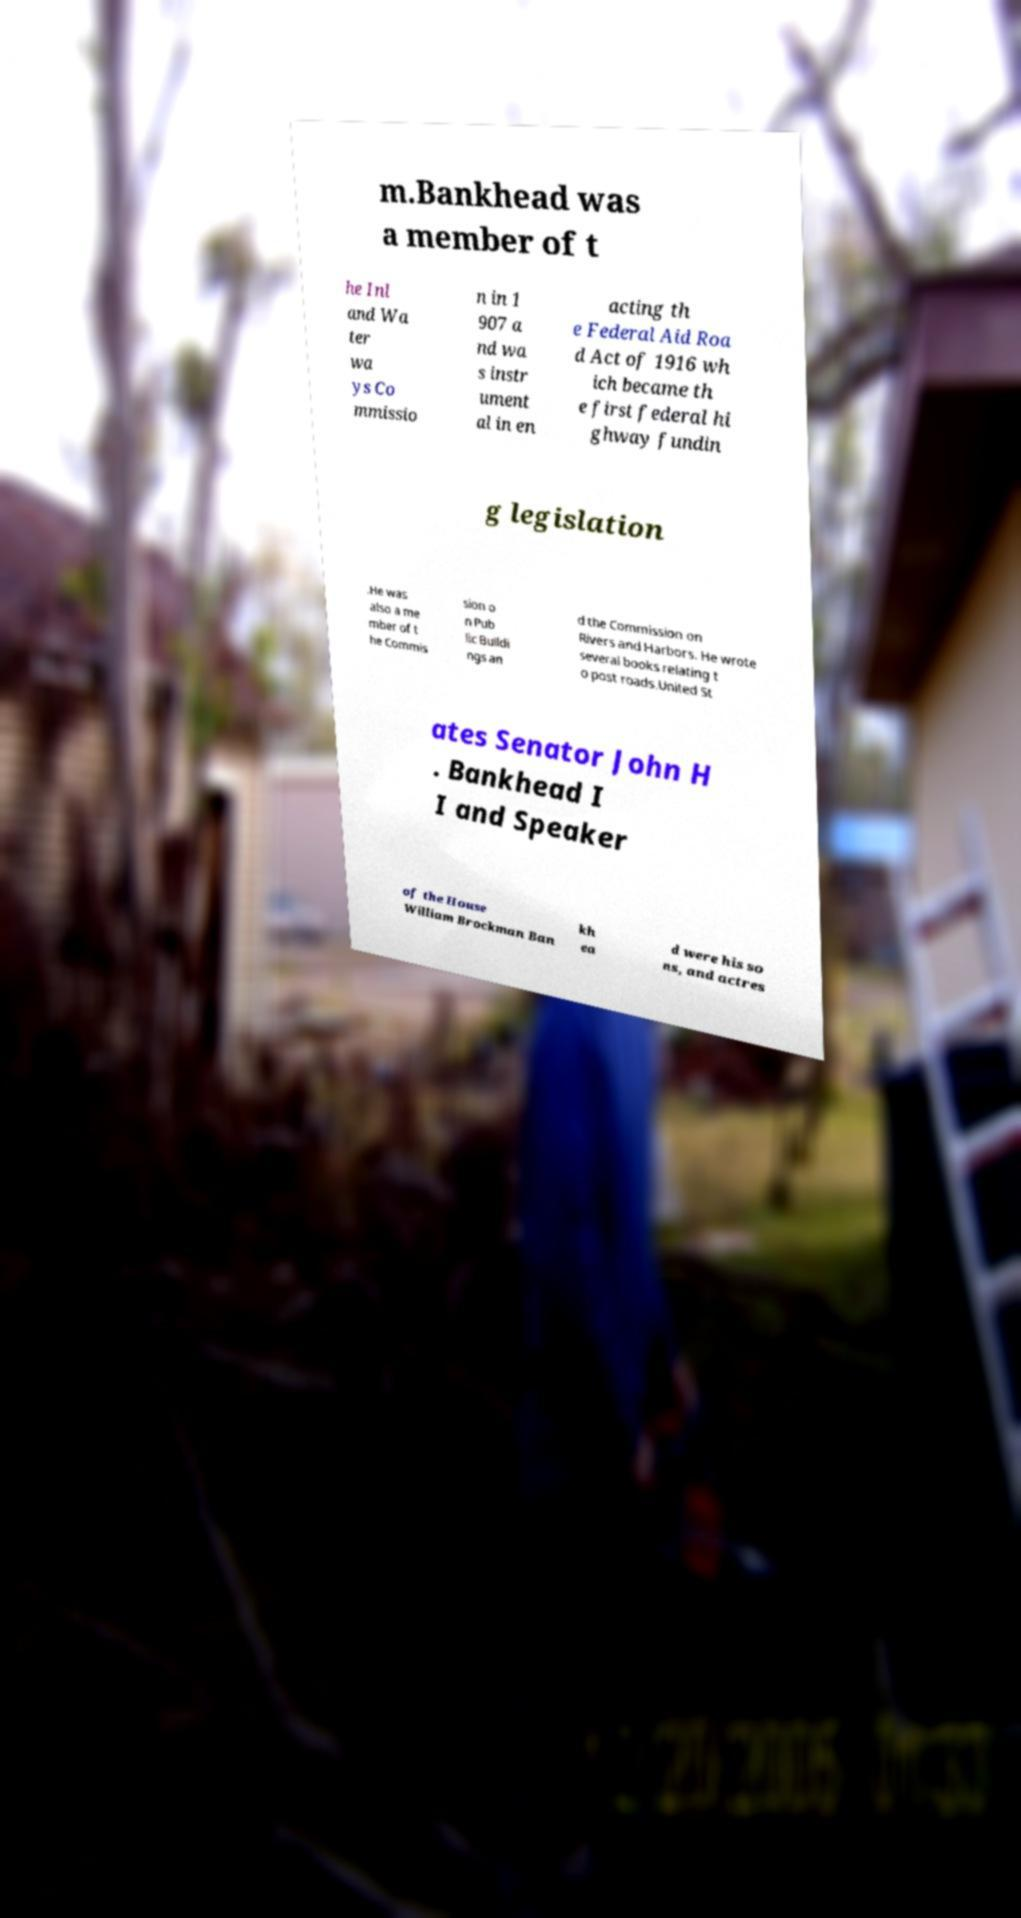Could you assist in decoding the text presented in this image and type it out clearly? m.Bankhead was a member of t he Inl and Wa ter wa ys Co mmissio n in 1 907 a nd wa s instr ument al in en acting th e Federal Aid Roa d Act of 1916 wh ich became th e first federal hi ghway fundin g legislation .He was also a me mber of t he Commis sion o n Pub lic Buildi ngs an d the Commission on Rivers and Harbors. He wrote several books relating t o post roads.United St ates Senator John H . Bankhead I I and Speaker of the House William Brockman Ban kh ea d were his so ns, and actres 